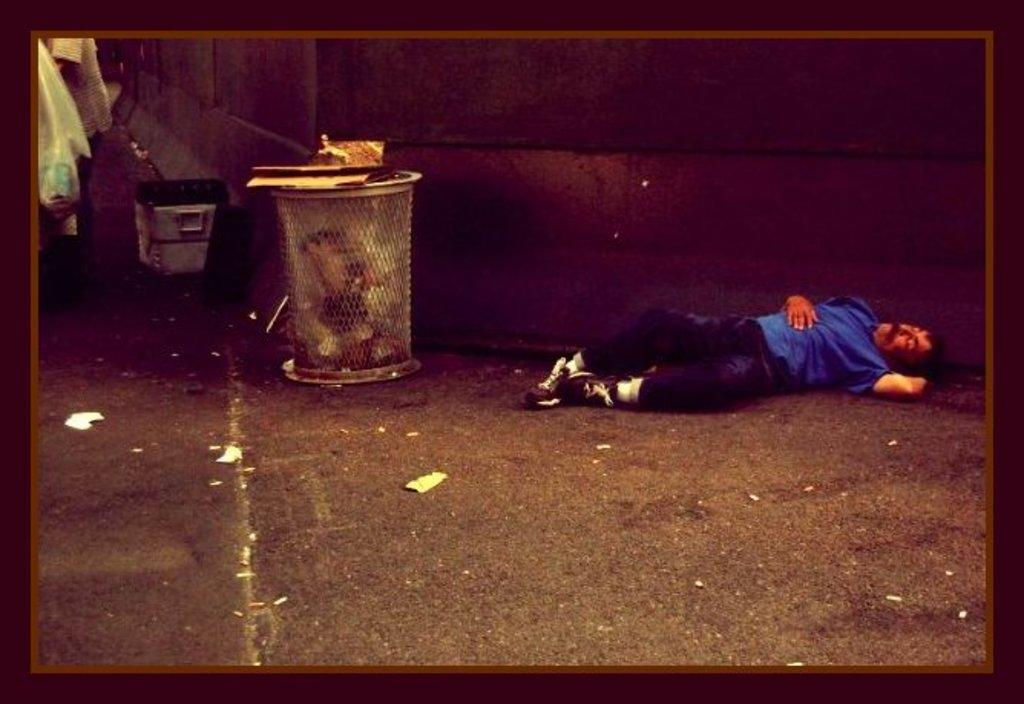Who is present in the image? There is a man in the image. What is the man's position in the image? The man is laying on the floor. What object is beside the man? There is a dustbin beside the man. Can you describe the object in the left top of the image? There is a plastic cover in the left top of the image. What type of car can be seen in the image? There is no car present in the image. How does the man use the basin in the image? There is no basin present in the image. 